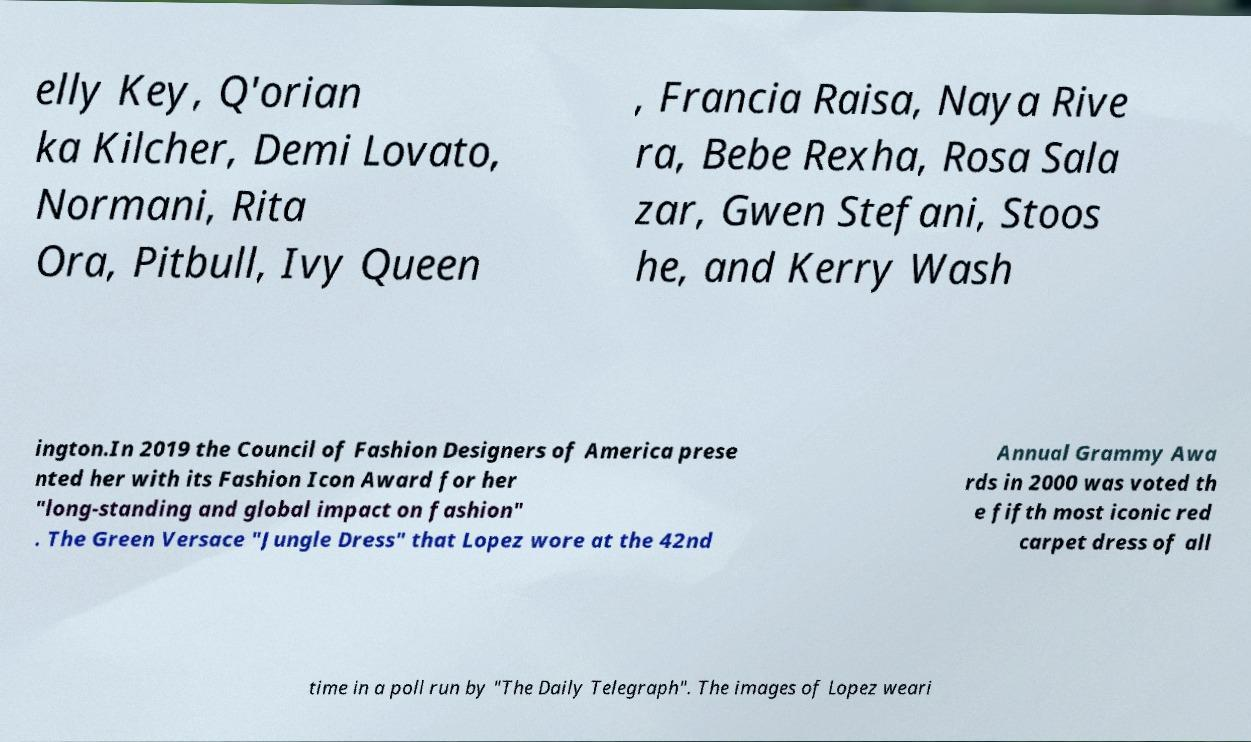Can you accurately transcribe the text from the provided image for me? elly Key, Q'orian ka Kilcher, Demi Lovato, Normani, Rita Ora, Pitbull, Ivy Queen , Francia Raisa, Naya Rive ra, Bebe Rexha, Rosa Sala zar, Gwen Stefani, Stoos he, and Kerry Wash ington.In 2019 the Council of Fashion Designers of America prese nted her with its Fashion Icon Award for her "long-standing and global impact on fashion" . The Green Versace "Jungle Dress" that Lopez wore at the 42nd Annual Grammy Awa rds in 2000 was voted th e fifth most iconic red carpet dress of all time in a poll run by "The Daily Telegraph". The images of Lopez weari 